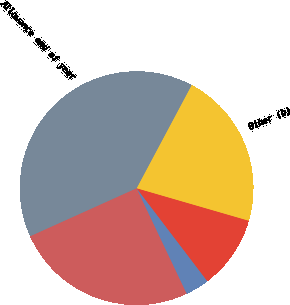Convert chart to OTSL. <chart><loc_0><loc_0><loc_500><loc_500><pie_chart><fcel>Allowance beginning of year<fcel>Net amounts charged to expense<fcel>Deductions (a)<fcel>Other (b)<fcel>Allowance end of year<nl><fcel>25.32%<fcel>3.29%<fcel>10.16%<fcel>21.69%<fcel>39.54%<nl></chart> 